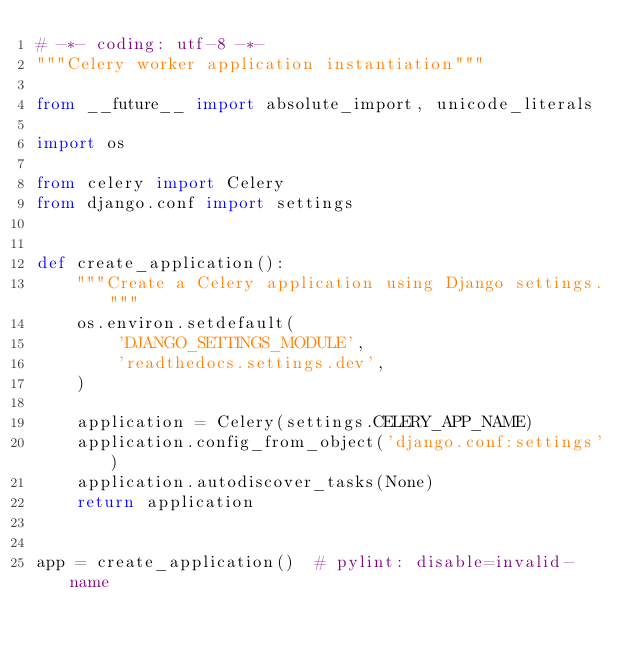Convert code to text. <code><loc_0><loc_0><loc_500><loc_500><_Python_># -*- coding: utf-8 -*-
"""Celery worker application instantiation"""

from __future__ import absolute_import, unicode_literals

import os

from celery import Celery
from django.conf import settings


def create_application():
    """Create a Celery application using Django settings."""
    os.environ.setdefault(
        'DJANGO_SETTINGS_MODULE',
        'readthedocs.settings.dev',
    )

    application = Celery(settings.CELERY_APP_NAME)
    application.config_from_object('django.conf:settings')
    application.autodiscover_tasks(None)
    return application


app = create_application()  # pylint: disable=invalid-name
</code> 